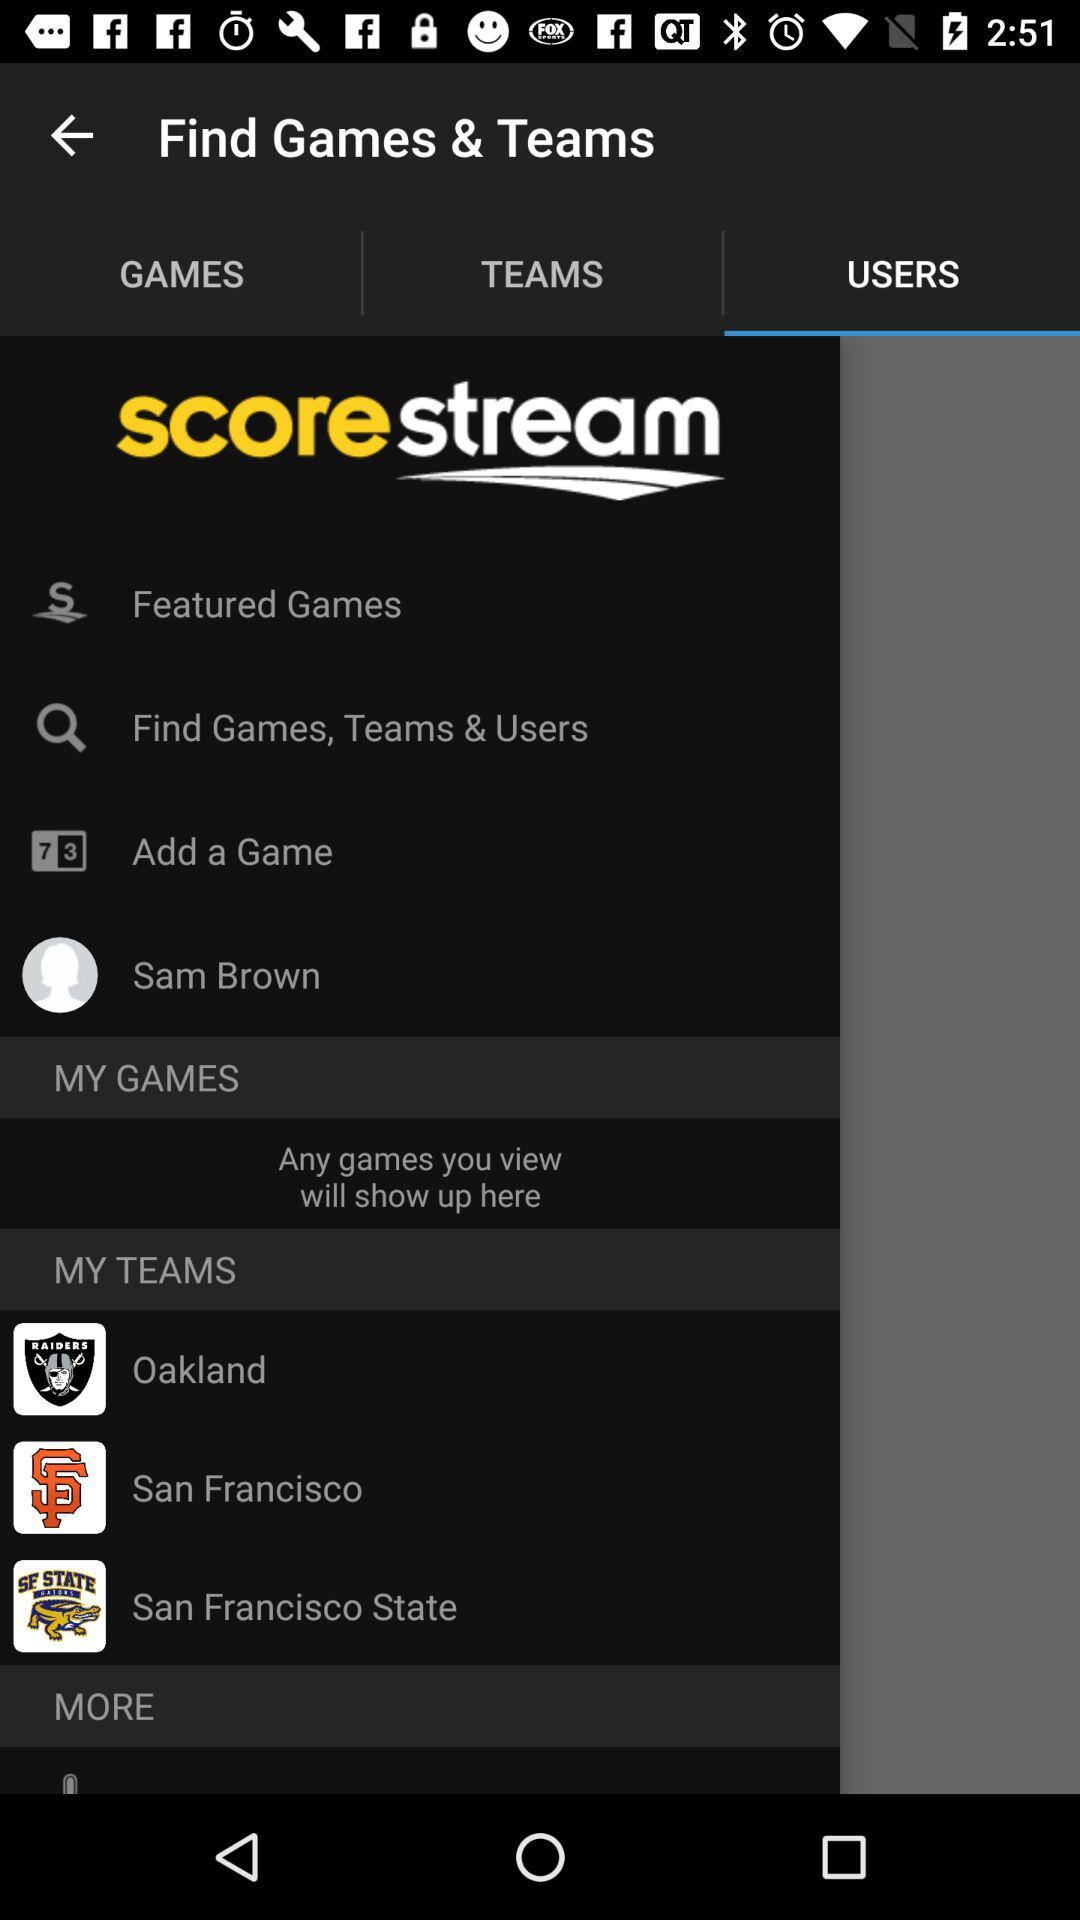Which tab is selected? The selected tab is "USERS". 